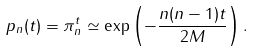Convert formula to latex. <formula><loc_0><loc_0><loc_500><loc_500>p _ { n } ( t ) = \pi _ { n } ^ { t } \simeq \exp \left ( - \frac { n ( n - 1 ) t } { 2 M } \right ) .</formula> 